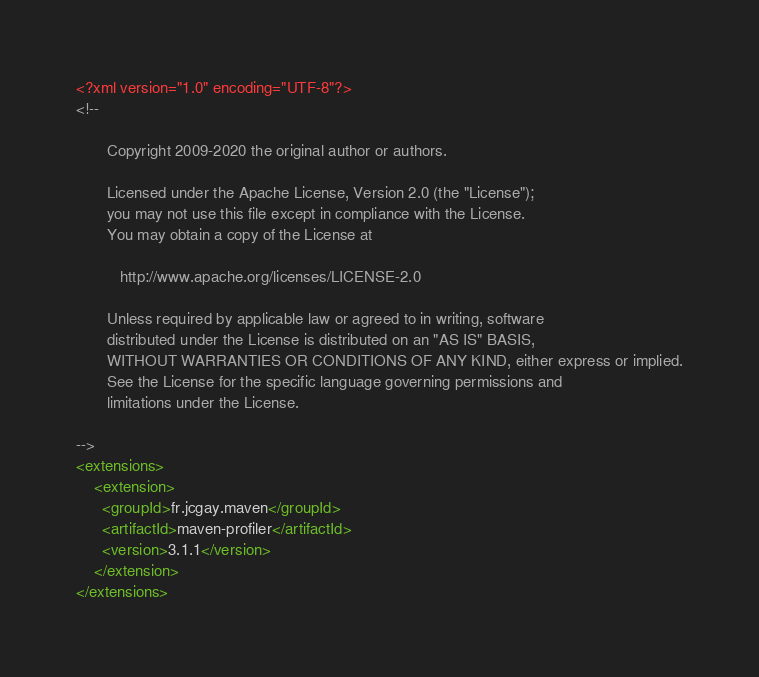Convert code to text. <code><loc_0><loc_0><loc_500><loc_500><_XML_><?xml version="1.0" encoding="UTF-8"?>
<!--

       Copyright 2009-2020 the original author or authors.

       Licensed under the Apache License, Version 2.0 (the "License");
       you may not use this file except in compliance with the License.
       You may obtain a copy of the License at

          http://www.apache.org/licenses/LICENSE-2.0

       Unless required by applicable law or agreed to in writing, software
       distributed under the License is distributed on an "AS IS" BASIS,
       WITHOUT WARRANTIES OR CONDITIONS OF ANY KIND, either express or implied.
       See the License for the specific language governing permissions and
       limitations under the License.

-->
<extensions>
    <extension>
      <groupId>fr.jcgay.maven</groupId>
      <artifactId>maven-profiler</artifactId>
      <version>3.1.1</version>
    </extension>
</extensions>
</code> 